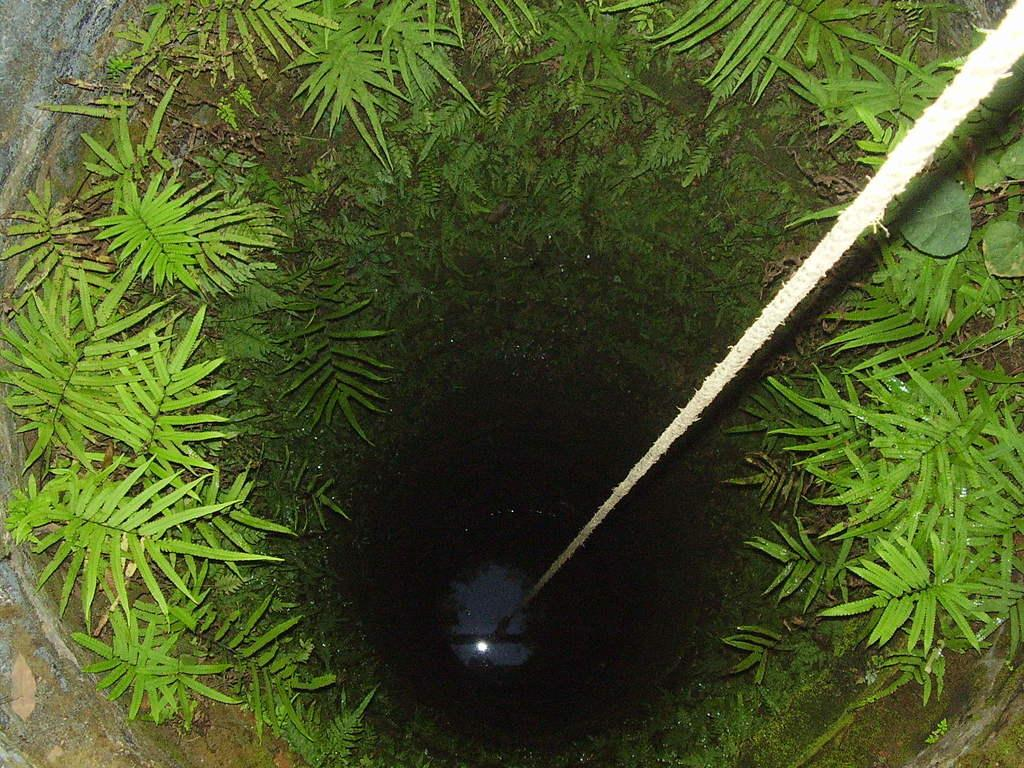What is the main structure in the picture? There is a well in the picture. What is inside the well? There is water in the well. How might someone access the water in the well? There is a rope associated with the well. What type of natural elements can be seen in the picture? There are leaves visible in the picture. What type of soda is being poured into the well in the picture? There is no soda present in the picture; it only features a well with water and leaves. 